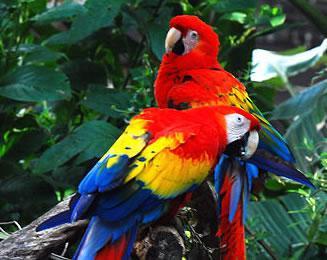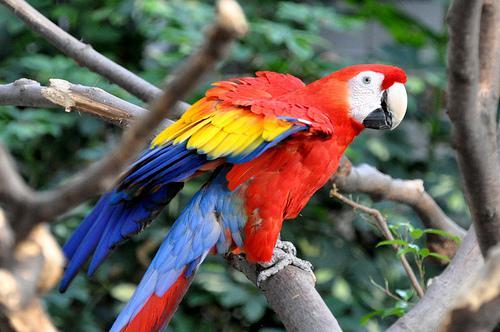The first image is the image on the left, the second image is the image on the right. Examine the images to the left and right. Is the description "Two birds are perched together in one of the images." accurate? Answer yes or no. Yes. 